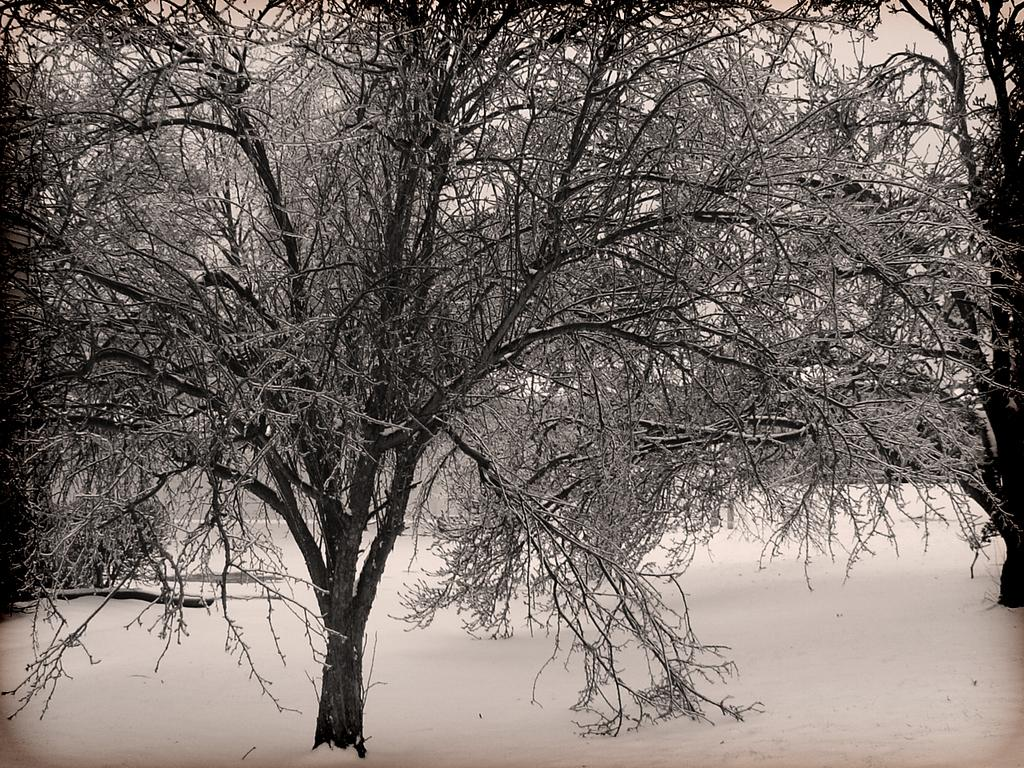What type of vegetation can be seen on both sides of the image? There are trees on the right side and the left side of the image. What is covering the ground in the image? There is snow at the bottom side of the image. What type of canvas is visible in the image? There is no canvas present in the image. Where is the playground located in the image? There is no playground present in the image. 